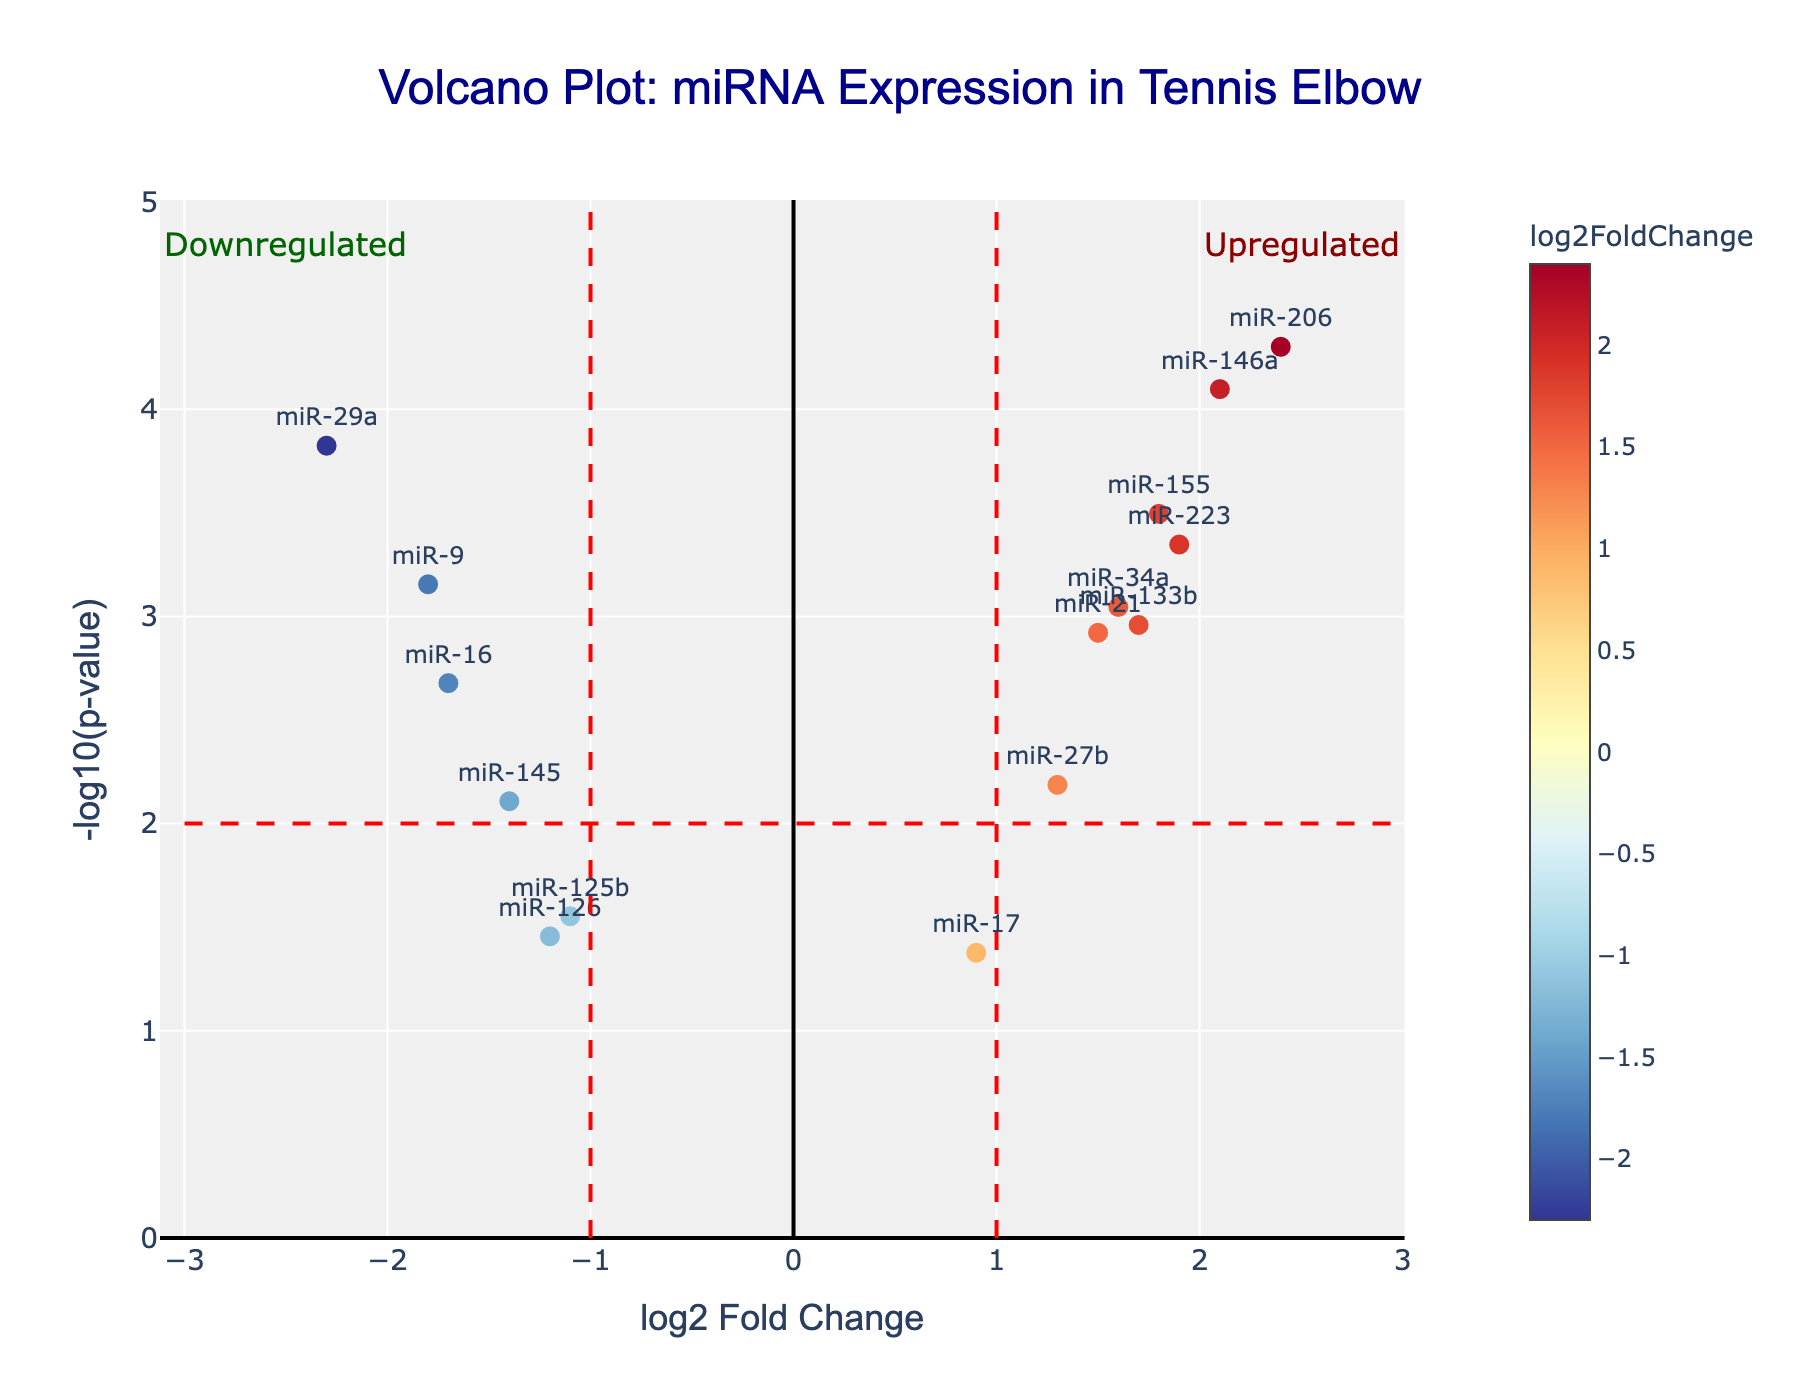How many miRNAs are displayed in the plot? Count the number of data points (dots) in the plot. Each dot represents one miRNA.
Answer: 14 What is highlighted by the red vertical dashed lines in the plot? The vertical lines at log2 fold change of -1 and 1 indicate the thresholds for considering miRNAs significantly downregulated or upregulated.
Answer: Fold change thresholds Which miRNA is the most upregulated in tennis elbow patients? Look for the miRNA with the highest positive log2 fold change. It's in the upper right part of the plot.
Answer: miR-206 Which miRNA has the lowest p-value, and what is its log2 fold change? Identify the miRNA with the highest -log10(p-value) (y-axis), since a lower p-value results in a higher -log10(p-value).
Answer: miR-206, 2.4 How many miRNAs are significantly upregulated at p-value < 0.01? Count the number of miRNAs in the right section of the plot (log2 fold change > 1) with -log10(p-value) > 2.
Answer: 6 What log2 fold change values indicate non-differentially expressed miRNAs according to the plot? Non-differentially expressed miRNAs are between the vertical lines at log2 fold change values between -1 and 1.
Answer: Between -1 and 1 Which miRNA is downregulated with the highest significance? Identify the miRNA with the highest -log10(p-value) on the left side of the plot (log2 fold change < -1).
Answer: miR-29a How do the sizes and colors of the markers help interpret the plot? The sizes are uniform, but colors indicate log2 fold change values. Warmer colors (red) represent upregulation, and cooler colors (blue) represent downregulation.
Answer: Colors for fold change What does the horizontal red dashed line indicate? The horizontal line at -log10(p-value) of 2 corresponds to a p-value threshold of 0.01 for statistical significance.
Answer: Significance threshold Which miRNAs have a log2 fold change close to zero but are still considered significant? Look for miRNAs near the y-axis (log2 fold change around 0) that have high -log10(p-value).
Answer: miR-21, miR-17 